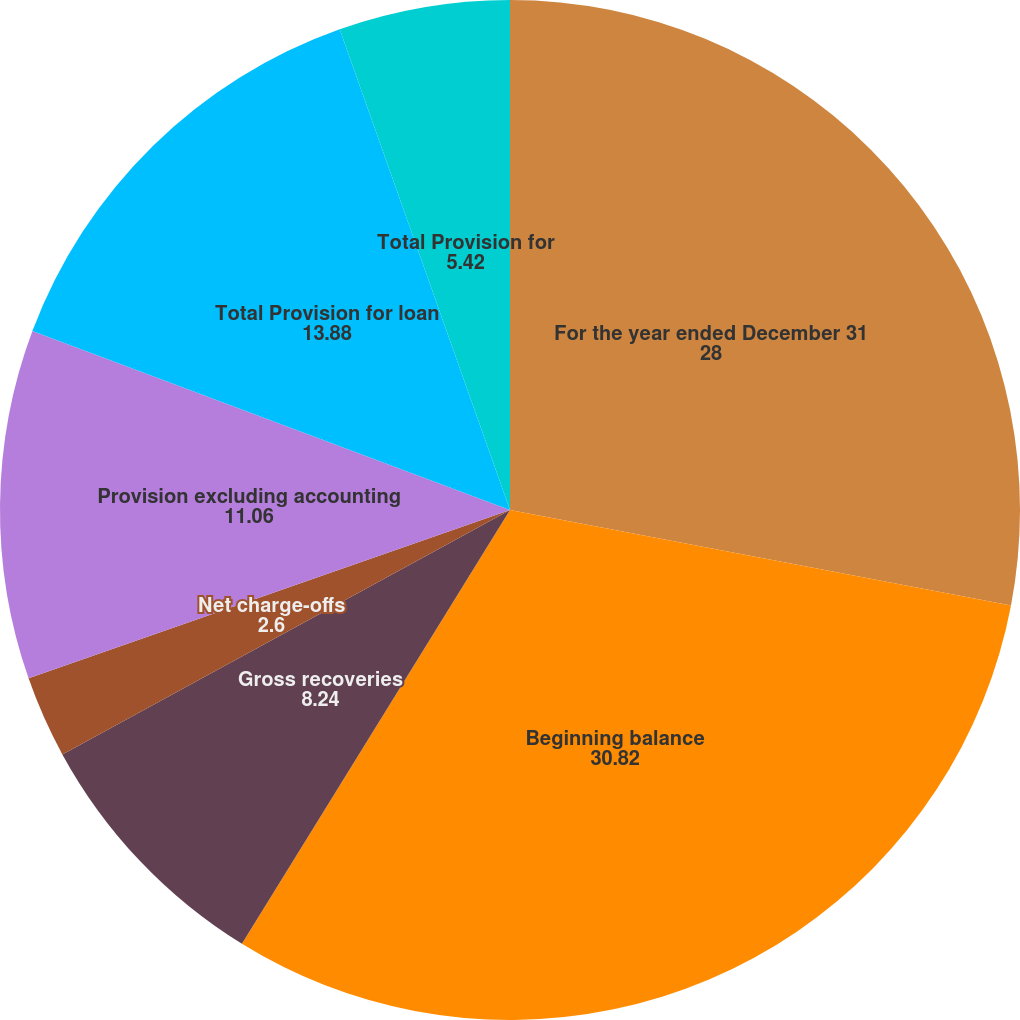Convert chart to OTSL. <chart><loc_0><loc_0><loc_500><loc_500><pie_chart><fcel>For the year ended December 31<fcel>Beginning balance<fcel>Gross recoveries<fcel>Net charge-offs<fcel>Provision excluding accounting<fcel>Total Provision for loan<fcel>Total Provision for<nl><fcel>28.0%<fcel>30.82%<fcel>8.24%<fcel>2.6%<fcel>11.06%<fcel>13.88%<fcel>5.42%<nl></chart> 